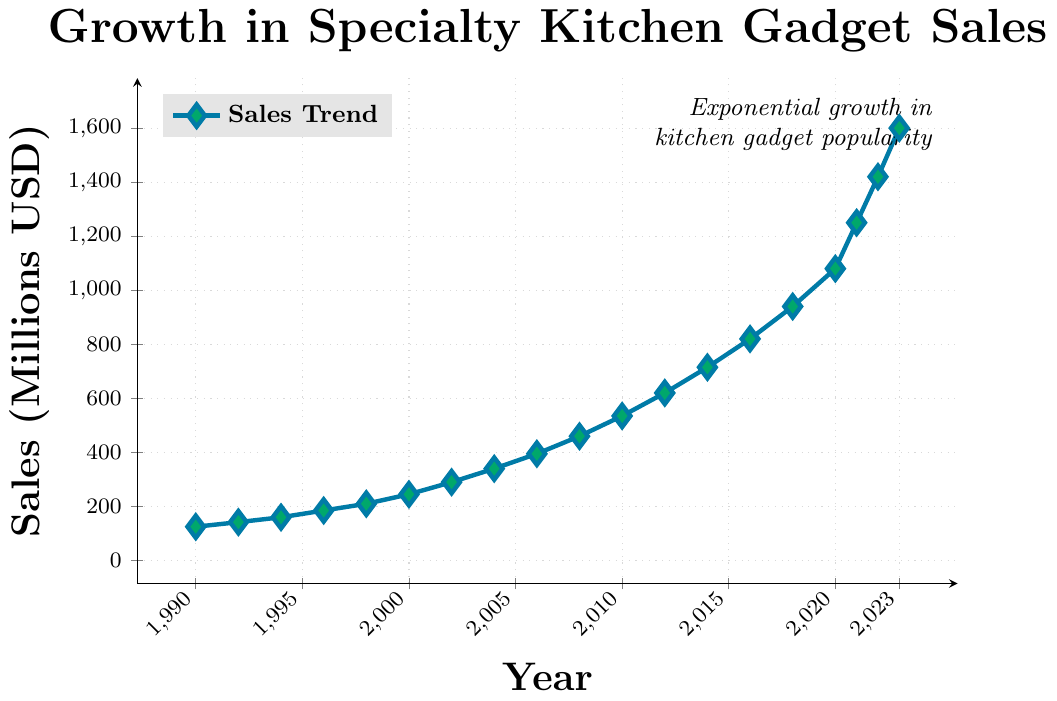What is the approximate difference in sales between 1990 and 2023? The sales in 1990 were 125 million USD, and in 2023, they were 1600 million USD. Subtracting these values gives 1600 - 125 = 1475.
Answer: 1475 million USD Between which years did the sales increase the most? Reviewing the plot, the largest increase in sales occurred between 2020 and 2021. Sales increased from 1080 million USD to 1250 million USD, resulting in an increase of 170 million USD.
Answer: 2020 and 2021 What's the average sales value over the entire period shown in the figure? Sum all the sales values and then divide by the number of data points: (125 + 142 + 160 + 185 + 210 + 245 + 290 + 340 + 395 + 460 + 535 + 620 + 715 + 820 + 940 + 1080 + 1250 + 1420 + 1600) / 19 = 6112 / 19 = 321.68.
Answer: 321.68 million USD How did sales change between 2000 and 2010? Sales in 2000 were 245 million USD, and in 2010, they were 535 million USD. The change is 535 - 245 = 290 million USD.
Answer: Increased by 290 million USD Which year saw sales surpass 1000 million USD for the first time? The plot shows that sales surpassed 1000 million USD for the first time in 2020, with a value of 1080 million USD.
Answer: 2020 How many years are there between the year with the lowest sales and the one with the highest sales? The lowest sales occurred in 1990, and the highest sales occurred in 2023. The number of years between them is 2023 - 1990 = 33 years.
Answer: 33 Which period experienced a steady increase without any decline? From 1990 to 2023, the plot shows a steady and consistent increase in sales without any declines.
Answer: 1990 to 2023 By how much did the sales increase every decade, on average, from 1990 to 2020? The periods are 1990-2000, 2000-2010, and 2010-2020: (245 - 125) for 1990-2000 = 120 million USD, (535 - 245) for 2000-2010 = 290 million USD, and (1080 - 535) for 2010-2020 = 545 million USD. The average per decade = (120 + 290 + 545) / 3 = 955 / 3 = 318.33 million USD.
Answer: 318.33 million USD What can be inferred about the trend of kitchen gadget popularity based on the sales trend shown in the chart? The chart shows a continuous increase in sales from 1990 to 2023, indicating a steady rise in the popularity of specialty kitchen gadgets and appliances over time.
Answer: Increasing popularity 